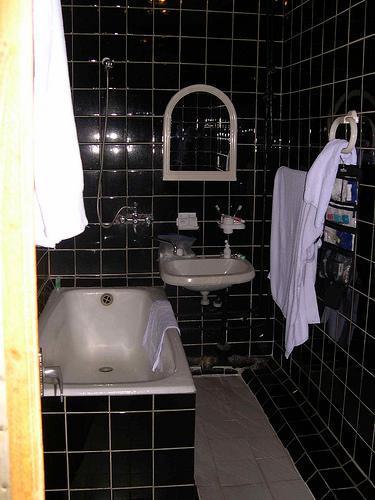How many sinks are there?
Give a very brief answer. 1. 